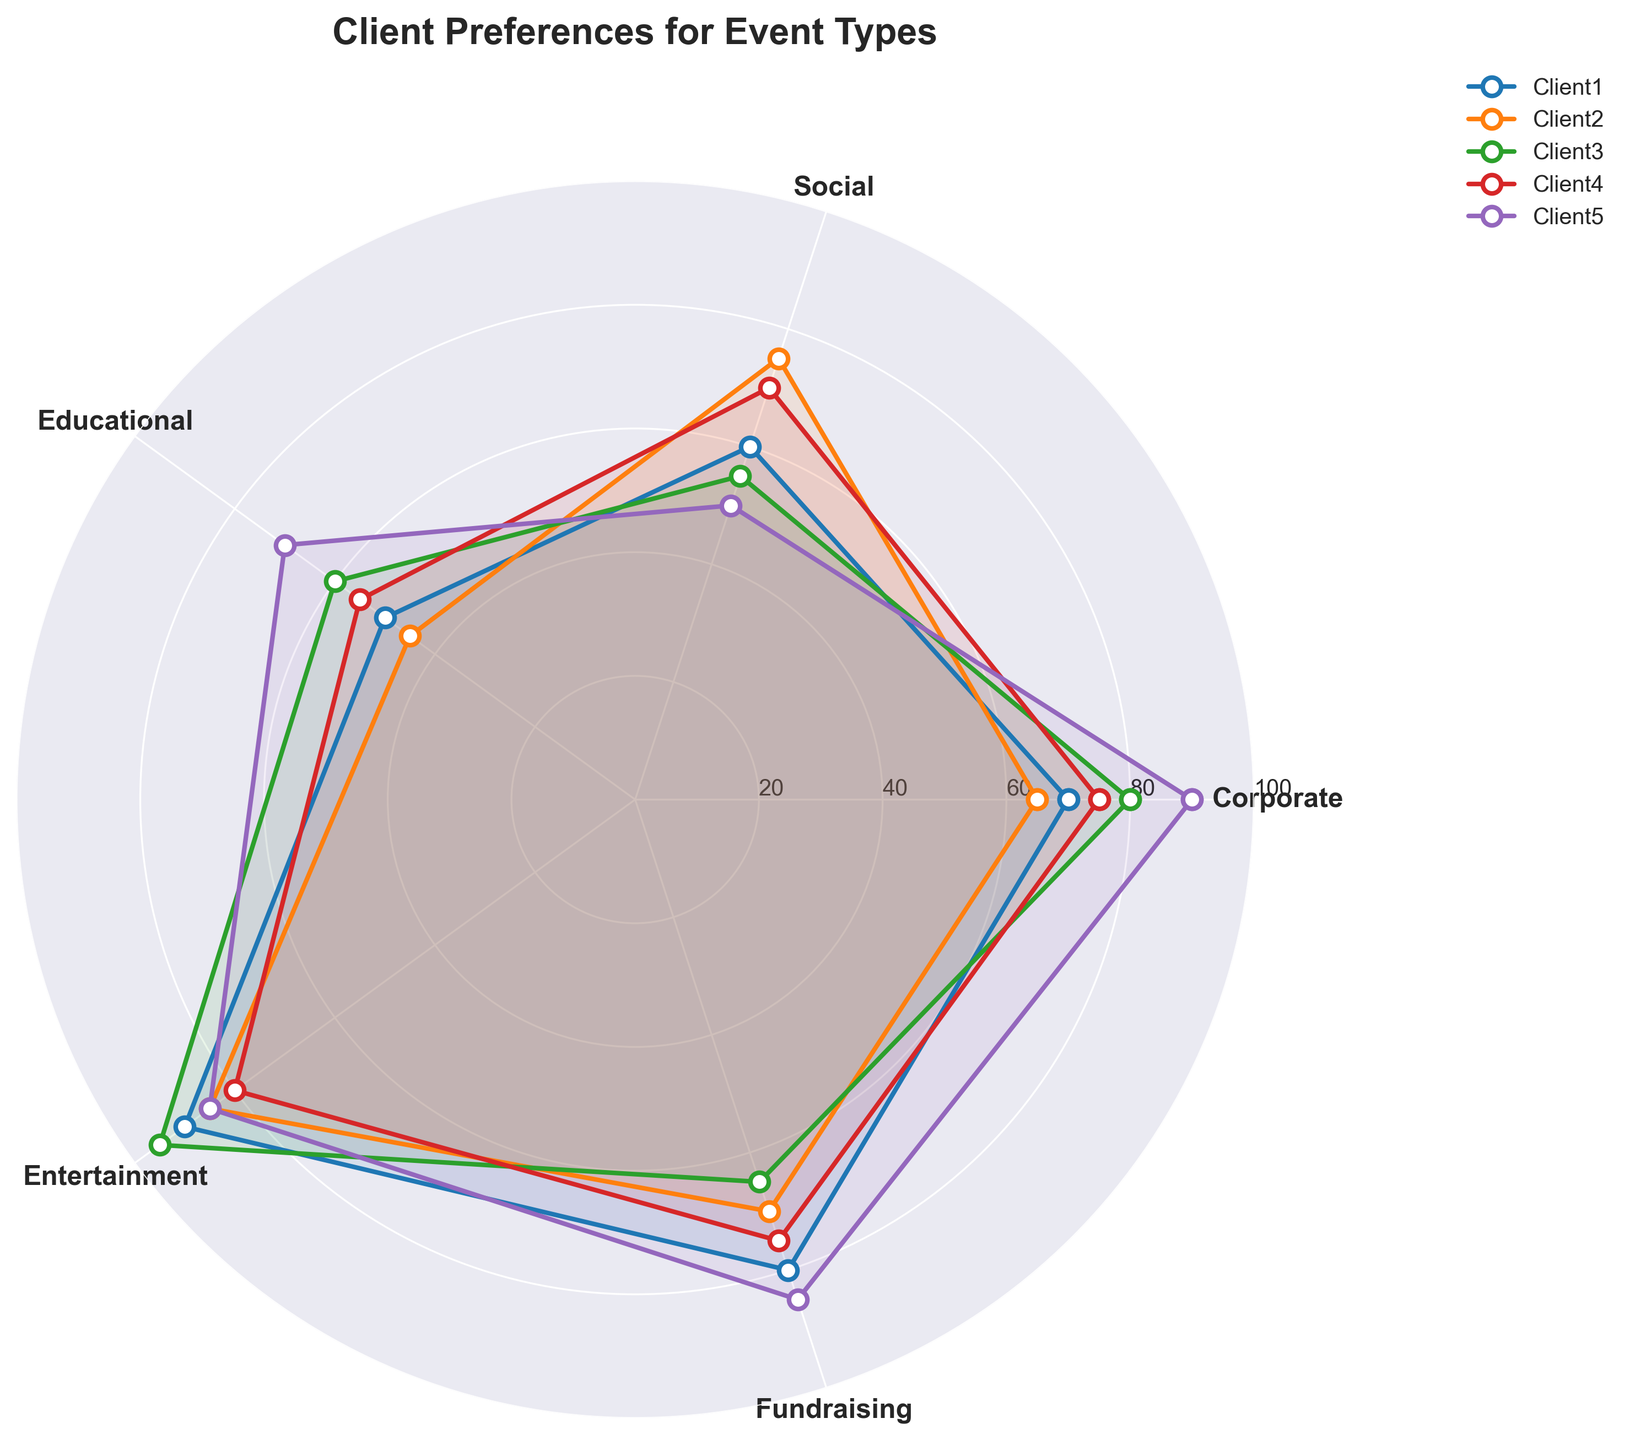What is the title of the figure? The title of the figure is usually displayed at the top of the chart. In this case, it reads "Client Preferences for Event Types".
Answer: Client Preferences for Event Types How many event types are represented in the figure? Look at the number of categories labeled around the circular axis. They are Corporate, Social, Educational, Entertainment, and Fundraising, which makes up 5 event types.
Answer: 5 Which client has the highest preference for Corporate events? The highest value for Corporate events is marked at the relevant angle for each client. By comparing, Client5 has the highest preference with a score of 90.
Answer: Client5 What is the range of Client1's preferences across all event types? To find the range, identify the highest and lowest values for Client1 (90 for Entertainment and 50 for Educational) and subtract the smallest value from the largest. Range = 90 - 50 = 40.
Answer: 40 Which event type has the most evenly distributed preferences across all clients? Look for the event type where the plotted lines for all clients are closest to each other. Fundraising shows the least variation in preferences (ranging from 65 to 85).
Answer: Fundraising Between Client2 and Client4, who prefers Social events more? Compare the values for Social events for both clients. Client2's value is 75, while Client4's value is 70. Client2 prefers Social events more.
Answer: Client2 What is the average preference for Educational events across all clients? Add the values for Educational events for all clients (50 + 45 + 60 + 55 + 70) and then divide by the number of clients (5). Average = (50+45+60+55+70)/5 =  280/5 = 56.
Answer: 56 Which client has the most balanced preferences across all event types (smallest range)? For each client, calculate the range of their preferences (highest value minus lowest value). Client1: 40, Client2: 40, Client3: 40, Client4: 25, Client5: 40. Client4 has the smallest range of 25.
Answer: Client4 Is there any event type where all clients have a preference score above 60? Check each event type to see if all clients have scores above 60. For the Corporate event type, all values (70, 65, 80, 75, 90) are above 60.
Answer: Yes, Corporate What is the difference in preference between Corporate and Entertainment events for Client3? Subtract the value for Entertainment from the value for Corporate for Client3. Difference = 95 - 80 = 15.
Answer: 15 